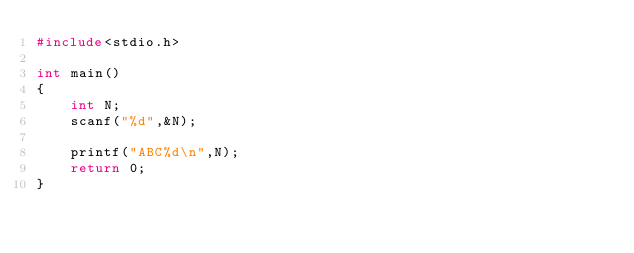Convert code to text. <code><loc_0><loc_0><loc_500><loc_500><_C_>#include<stdio.h>

int main()
{
    int N;
    scanf("%d",&N);

    printf("ABC%d\n",N);
    return 0;
}
</code> 